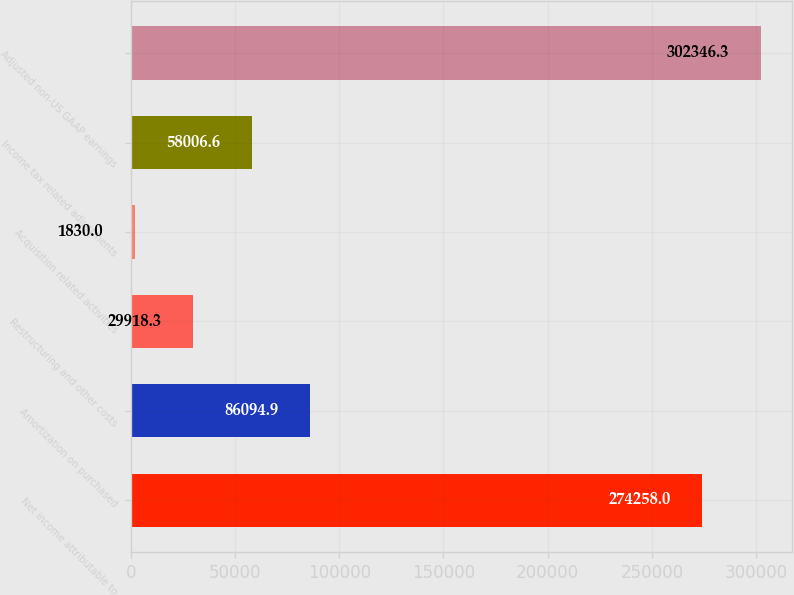Convert chart to OTSL. <chart><loc_0><loc_0><loc_500><loc_500><bar_chart><fcel>Net income attributable to<fcel>Amortization on purchased<fcel>Restructuring and other costs<fcel>Acquisition related activities<fcel>Income tax related adjustments<fcel>Adjusted non-US GAAP earnings<nl><fcel>274258<fcel>86094.9<fcel>29918.3<fcel>1830<fcel>58006.6<fcel>302346<nl></chart> 